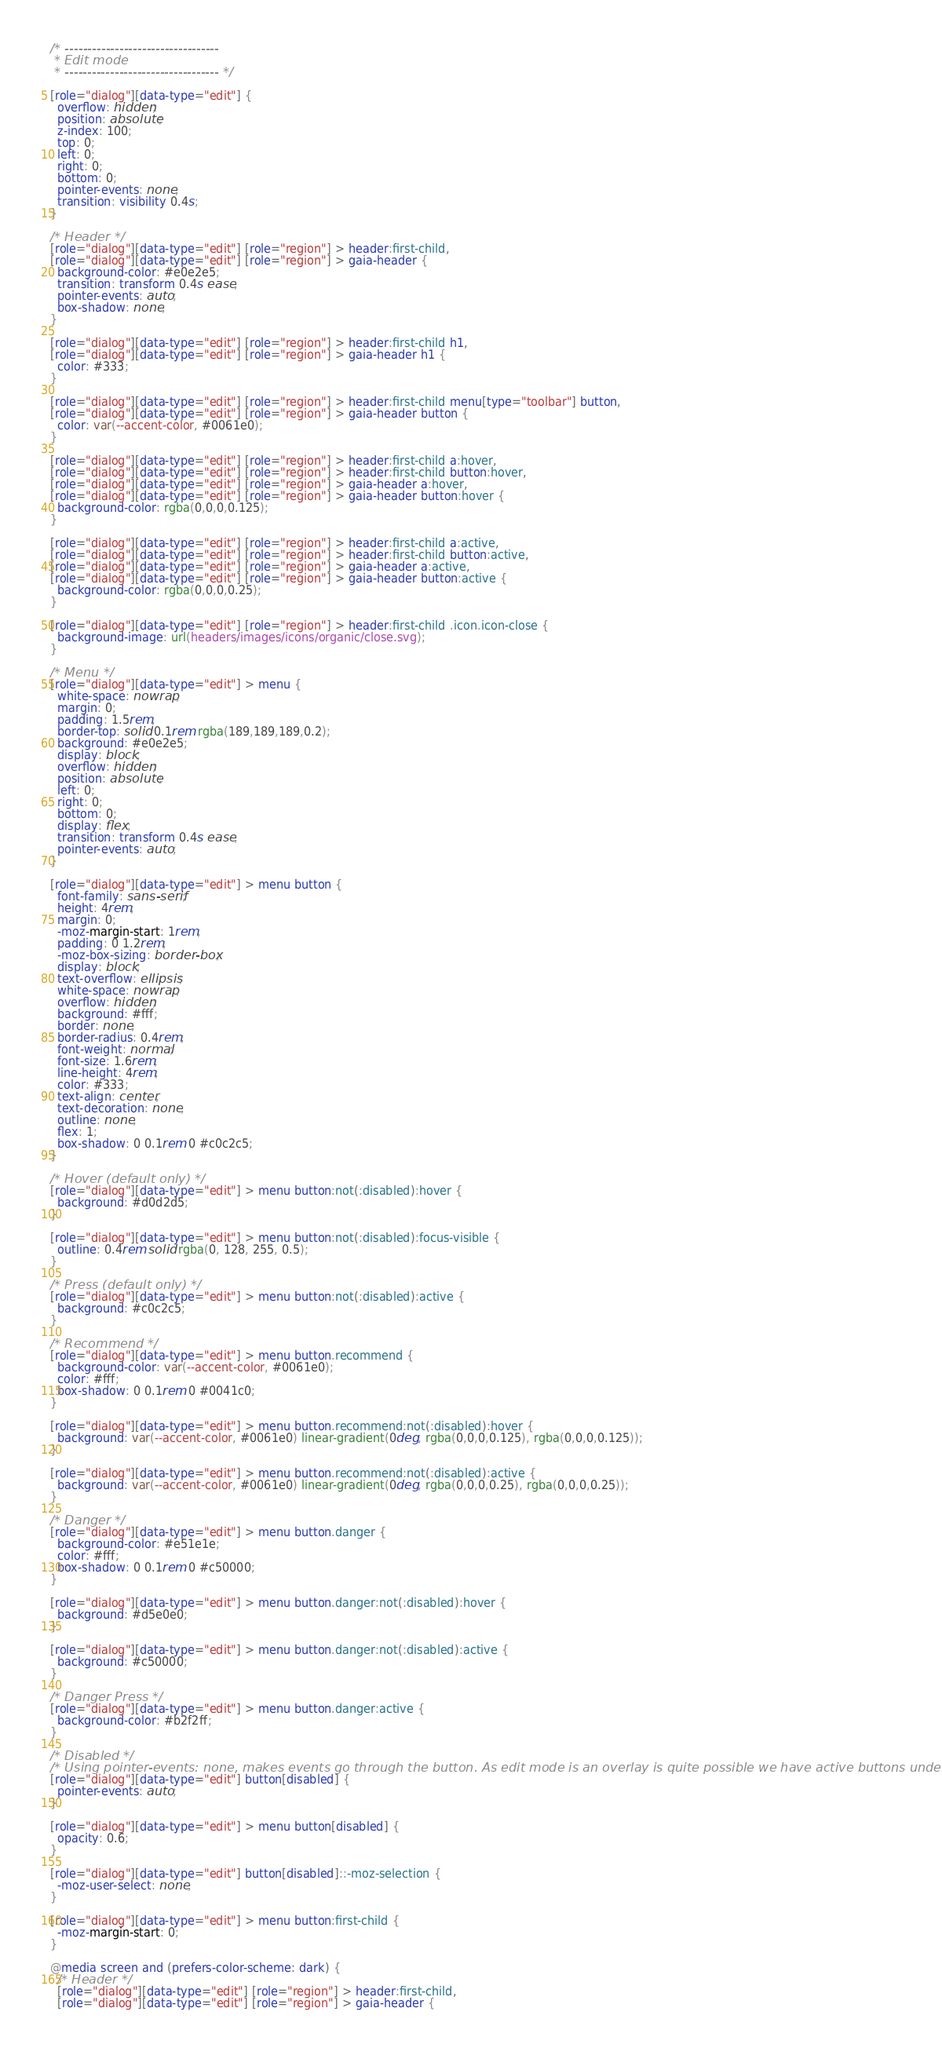Convert code to text. <code><loc_0><loc_0><loc_500><loc_500><_CSS_>/* ----------------------------------
 * Edit mode
 * ---------------------------------- */

[role="dialog"][data-type="edit"] {
  overflow: hidden;
  position: absolute;
  z-index: 100;
  top: 0;
  left: 0;
  right: 0;
  bottom: 0;
  pointer-events: none;
  transition: visibility 0.4s;
}

/* Header */
[role="dialog"][data-type="edit"] [role="region"] > header:first-child,
[role="dialog"][data-type="edit"] [role="region"] > gaia-header {
  background-color: #e0e2e5;
  transition: transform 0.4s ease;
  pointer-events: auto;
  box-shadow: none;
}

[role="dialog"][data-type="edit"] [role="region"] > header:first-child h1,
[role="dialog"][data-type="edit"] [role="region"] > gaia-header h1 {
  color: #333;
}

[role="dialog"][data-type="edit"] [role="region"] > header:first-child menu[type="toolbar"] button,
[role="dialog"][data-type="edit"] [role="region"] > gaia-header button {
  color: var(--accent-color, #0061e0);
}

[role="dialog"][data-type="edit"] [role="region"] > header:first-child a:hover,
[role="dialog"][data-type="edit"] [role="region"] > header:first-child button:hover,
[role="dialog"][data-type="edit"] [role="region"] > gaia-header a:hover,
[role="dialog"][data-type="edit"] [role="region"] > gaia-header button:hover {
  background-color: rgba(0,0,0,0.125);
}

[role="dialog"][data-type="edit"] [role="region"] > header:first-child a:active,
[role="dialog"][data-type="edit"] [role="region"] > header:first-child button:active,
[role="dialog"][data-type="edit"] [role="region"] > gaia-header a:active,
[role="dialog"][data-type="edit"] [role="region"] > gaia-header button:active {
  background-color: rgba(0,0,0,0.25);
}

[role="dialog"][data-type="edit"] [role="region"] > header:first-child .icon.icon-close {
  background-image: url(headers/images/icons/organic/close.svg);
}

/* Menu */
[role="dialog"][data-type="edit"] > menu {
  white-space: nowrap;
  margin: 0;
  padding: 1.5rem;
  border-top: solid 0.1rem rgba(189,189,189,0.2);
  background: #e0e2e5;
  display: block;
  overflow: hidden;
  position: absolute;
  left: 0;
  right: 0;
  bottom: 0;
  display: flex;
  transition: transform 0.4s ease;
  pointer-events: auto;
}

[role="dialog"][data-type="edit"] > menu button {
  font-family: sans-serif;
  height: 4rem;
  margin: 0;
  -moz-margin-start: 1rem;
  padding: 0 1.2rem;
  -moz-box-sizing: border-box;
  display: block;
  text-overflow: ellipsis;
  white-space: nowrap;
  overflow: hidden;
  background: #fff;
  border: none;
  border-radius: 0.4rem;
  font-weight: normal;
  font-size: 1.6rem;
  line-height: 4rem;
  color: #333;
  text-align: center;
  text-decoration: none;
  outline: none;
  flex: 1;
  box-shadow: 0 0.1rem 0 #c0c2c5;
}

/* Hover (default only) */
[role="dialog"][data-type="edit"] > menu button:not(:disabled):hover {
  background: #d0d2d5;
}

[role="dialog"][data-type="edit"] > menu button:not(:disabled):focus-visible {
  outline: 0.4rem solid rgba(0, 128, 255, 0.5);
}

/* Press (default only) */
[role="dialog"][data-type="edit"] > menu button:not(:disabled):active {
  background: #c0c2c5;
}

/* Recommend */
[role="dialog"][data-type="edit"] > menu button.recommend {
  background-color: var(--accent-color, #0061e0);
  color: #fff;
  box-shadow: 0 0.1rem 0 #0041c0;
}

[role="dialog"][data-type="edit"] > menu button.recommend:not(:disabled):hover {
  background: var(--accent-color, #0061e0) linear-gradient(0deg, rgba(0,0,0,0.125), rgba(0,0,0,0.125));
}

[role="dialog"][data-type="edit"] > menu button.recommend:not(:disabled):active {
  background: var(--accent-color, #0061e0) linear-gradient(0deg, rgba(0,0,0,0.25), rgba(0,0,0,0.25));
}

/* Danger */
[role="dialog"][data-type="edit"] > menu button.danger {
  background-color: #e51e1e;
  color: #fff;
  box-shadow: 0 0.1rem 0 #c50000;
}

[role="dialog"][data-type="edit"] > menu button.danger:not(:disabled):hover {
  background: #d5e0e0;
}

[role="dialog"][data-type="edit"] > menu button.danger:not(:disabled):active {
  background: #c50000;
}

/* Danger Press */
[role="dialog"][data-type="edit"] > menu button.danger:active {
  background-color: #b2f2ff;
}

/* Disabled */
/* Using pointer-events: none, makes events go through the button. As edit mode is an overlay is quite possible we have active buttons underneath */
[role="dialog"][data-type="edit"] button[disabled] {
  pointer-events: auto;
}

[role="dialog"][data-type="edit"] > menu button[disabled] {
  opacity: 0.6;
}

[role="dialog"][data-type="edit"] button[disabled]::-moz-selection {
  -moz-user-select: none;
}

[role="dialog"][data-type="edit"] > menu button:first-child {
  -moz-margin-start: 0;
}

@media screen and (prefers-color-scheme: dark) {
  /* Header */
  [role="dialog"][data-type="edit"] [role="region"] > header:first-child,
  [role="dialog"][data-type="edit"] [role="region"] > gaia-header {</code> 